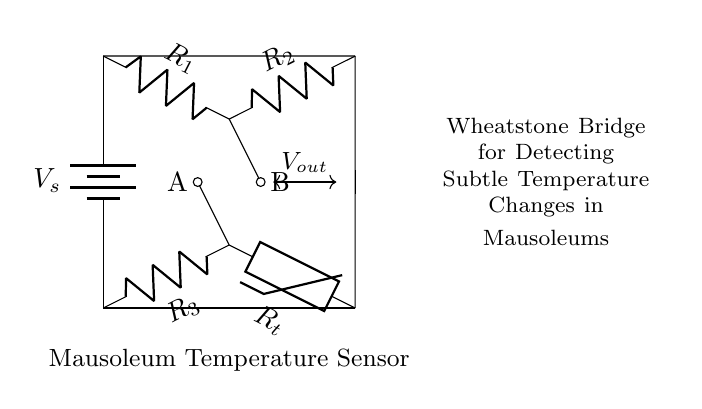What type of bridge is depicted in the circuit? The circuit shown is a Wheatstone Bridge, which is used to measure unknown resistances by balancing two legs of a circuit.
Answer: Wheatstone Bridge What component is used to measure temperature in the circuit? The thermistor is the component that varies its resistance with temperature changes, allowing the circuit to detect subtle temperature variations.
Answer: Thermistor What is the total number of resistors in the circuit? There are three resistors labeled in the circuit: R1, R2, and R3. Each plays a role in forming the Wheatstone bridge configuration.
Answer: Three How is the output voltage indicated in the circuit? The output voltage is indicated between points A and B, which are connected to the top and bottom junctions of the resistors within the bridge setup.
Answer: Vout What is the purpose of this Wheatstone bridge circuit? The primary purpose is to detect subtle temperature changes specifically within mausoleum environments by measuring variations caused by the thermistor.
Answer: Detect temperature changes How many voltage sources are present in the circuit? There is one voltage source denoted as Vs in the circuit, which powers the Wheatstone bridge configuration.
Answer: One What does the label "Mausoleum Temperature Sensor" imply about the application of the circuit? It implies that the circuit is intended for environmental monitoring within mausoleums, likely designed to protect artifacts or remains by ensuring stable temperature conditions.
Answer: Environmental monitoring 